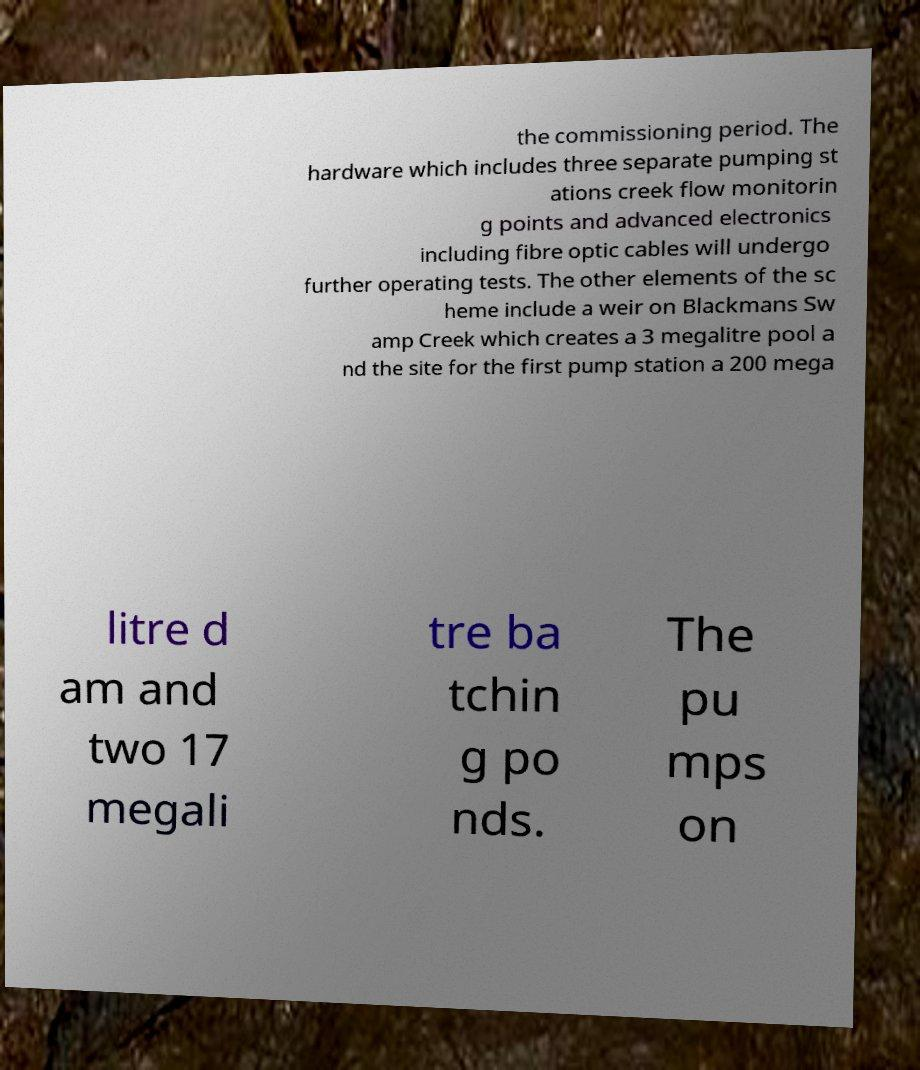For documentation purposes, I need the text within this image transcribed. Could you provide that? the commissioning period. The hardware which includes three separate pumping st ations creek flow monitorin g points and advanced electronics including fibre optic cables will undergo further operating tests. The other elements of the sc heme include a weir on Blackmans Sw amp Creek which creates a 3 megalitre pool a nd the site for the first pump station a 200 mega litre d am and two 17 megali tre ba tchin g po nds. The pu mps on 